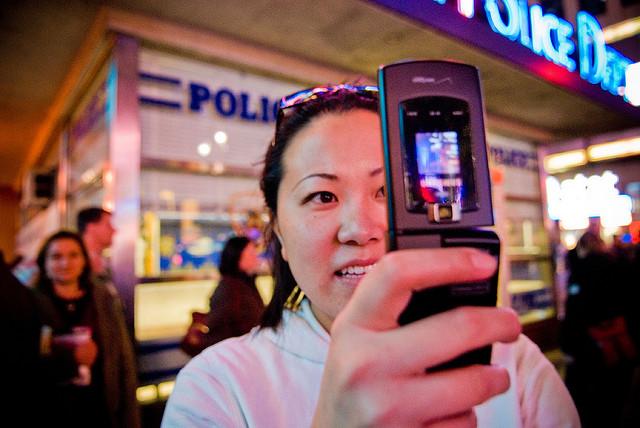What is she holding?
Give a very brief answer. Cell phone. Is she using her phone?
Keep it brief. Yes. What kind of building is in the picture?
Concise answer only. Police station. 